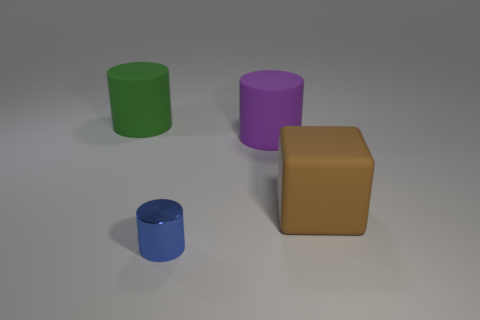Subtract all large purple cylinders. How many cylinders are left? 2 Subtract all blue cylinders. How many cylinders are left? 2 Add 1 blue objects. How many objects exist? 5 Subtract 0 gray cubes. How many objects are left? 4 Subtract all cylinders. How many objects are left? 1 Subtract 1 cylinders. How many cylinders are left? 2 Subtract all brown cylinders. Subtract all yellow balls. How many cylinders are left? 3 Subtract all brown cylinders. How many yellow cubes are left? 0 Subtract all rubber things. Subtract all large cubes. How many objects are left? 0 Add 2 green rubber cylinders. How many green rubber cylinders are left? 3 